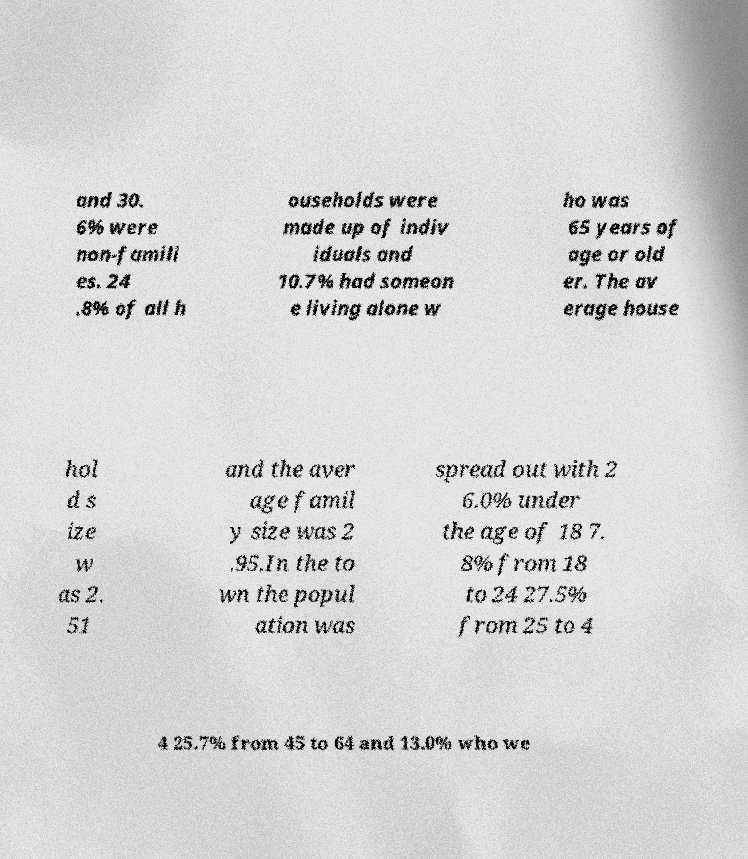I need the written content from this picture converted into text. Can you do that? and 30. 6% were non-famili es. 24 .8% of all h ouseholds were made up of indiv iduals and 10.7% had someon e living alone w ho was 65 years of age or old er. The av erage house hol d s ize w as 2. 51 and the aver age famil y size was 2 .95.In the to wn the popul ation was spread out with 2 6.0% under the age of 18 7. 8% from 18 to 24 27.5% from 25 to 4 4 25.7% from 45 to 64 and 13.0% who we 